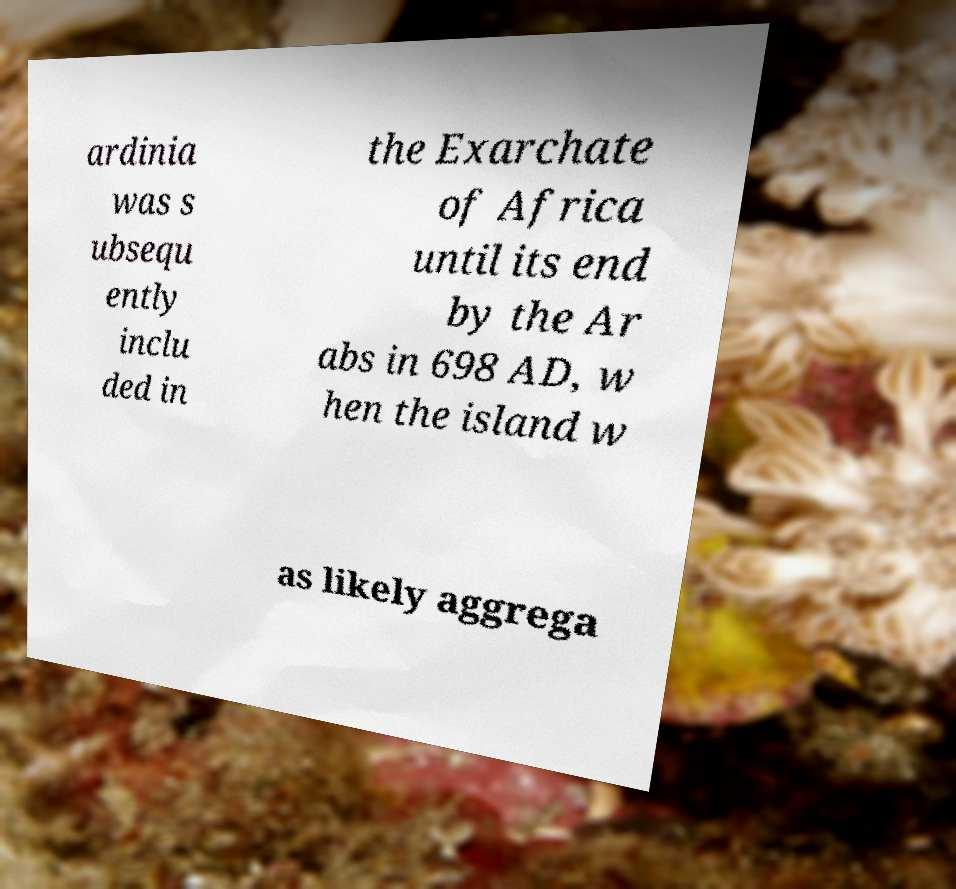Could you assist in decoding the text presented in this image and type it out clearly? ardinia was s ubsequ ently inclu ded in the Exarchate of Africa until its end by the Ar abs in 698 AD, w hen the island w as likely aggrega 